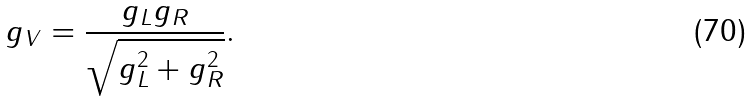<formula> <loc_0><loc_0><loc_500><loc_500>g _ { V } = \frac { g _ { L } g _ { R } } { \sqrt { g _ { L } ^ { 2 } + g _ { R } ^ { 2 } } } .</formula> 